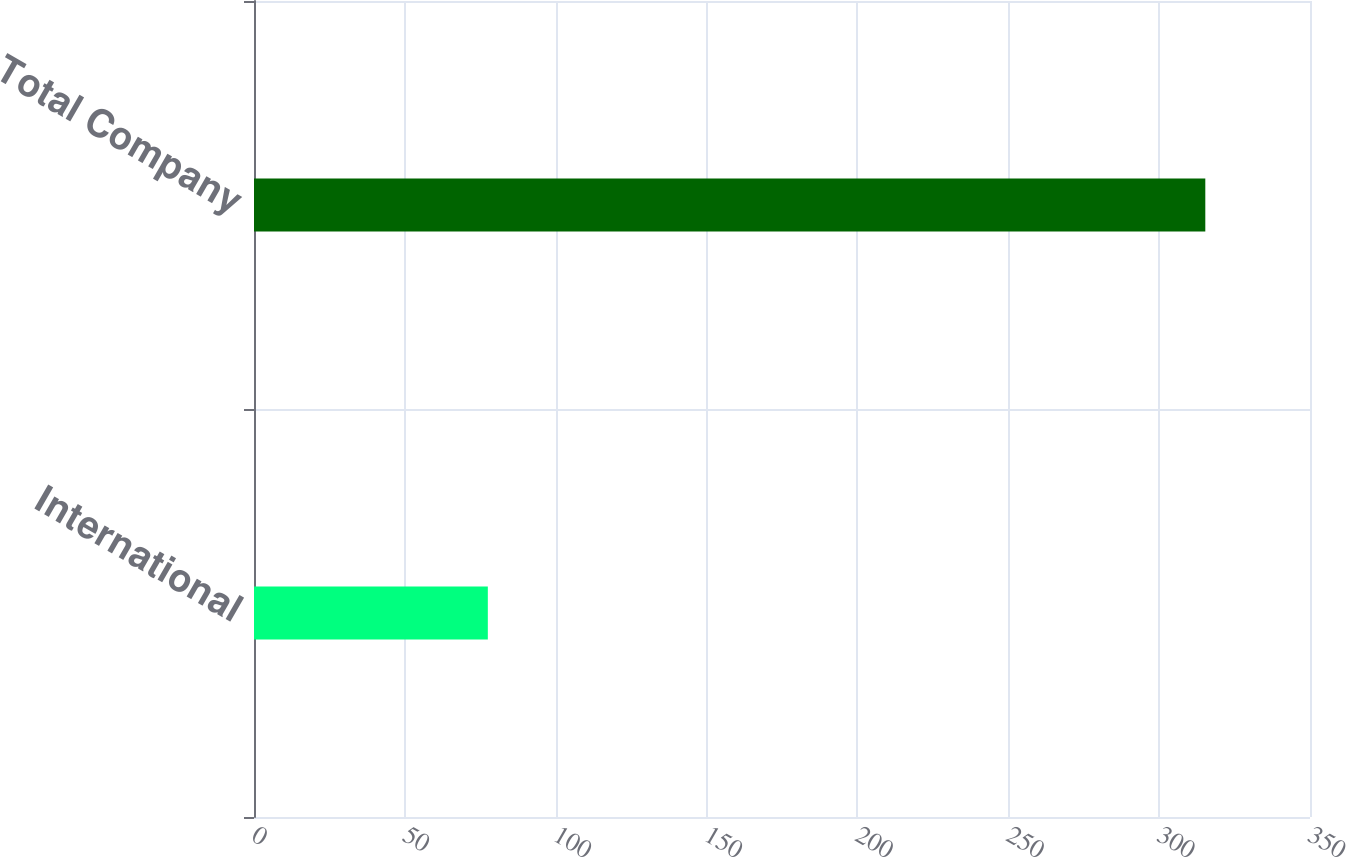Convert chart to OTSL. <chart><loc_0><loc_0><loc_500><loc_500><bar_chart><fcel>International<fcel>Total Company<nl><fcel>77.5<fcel>315.3<nl></chart> 